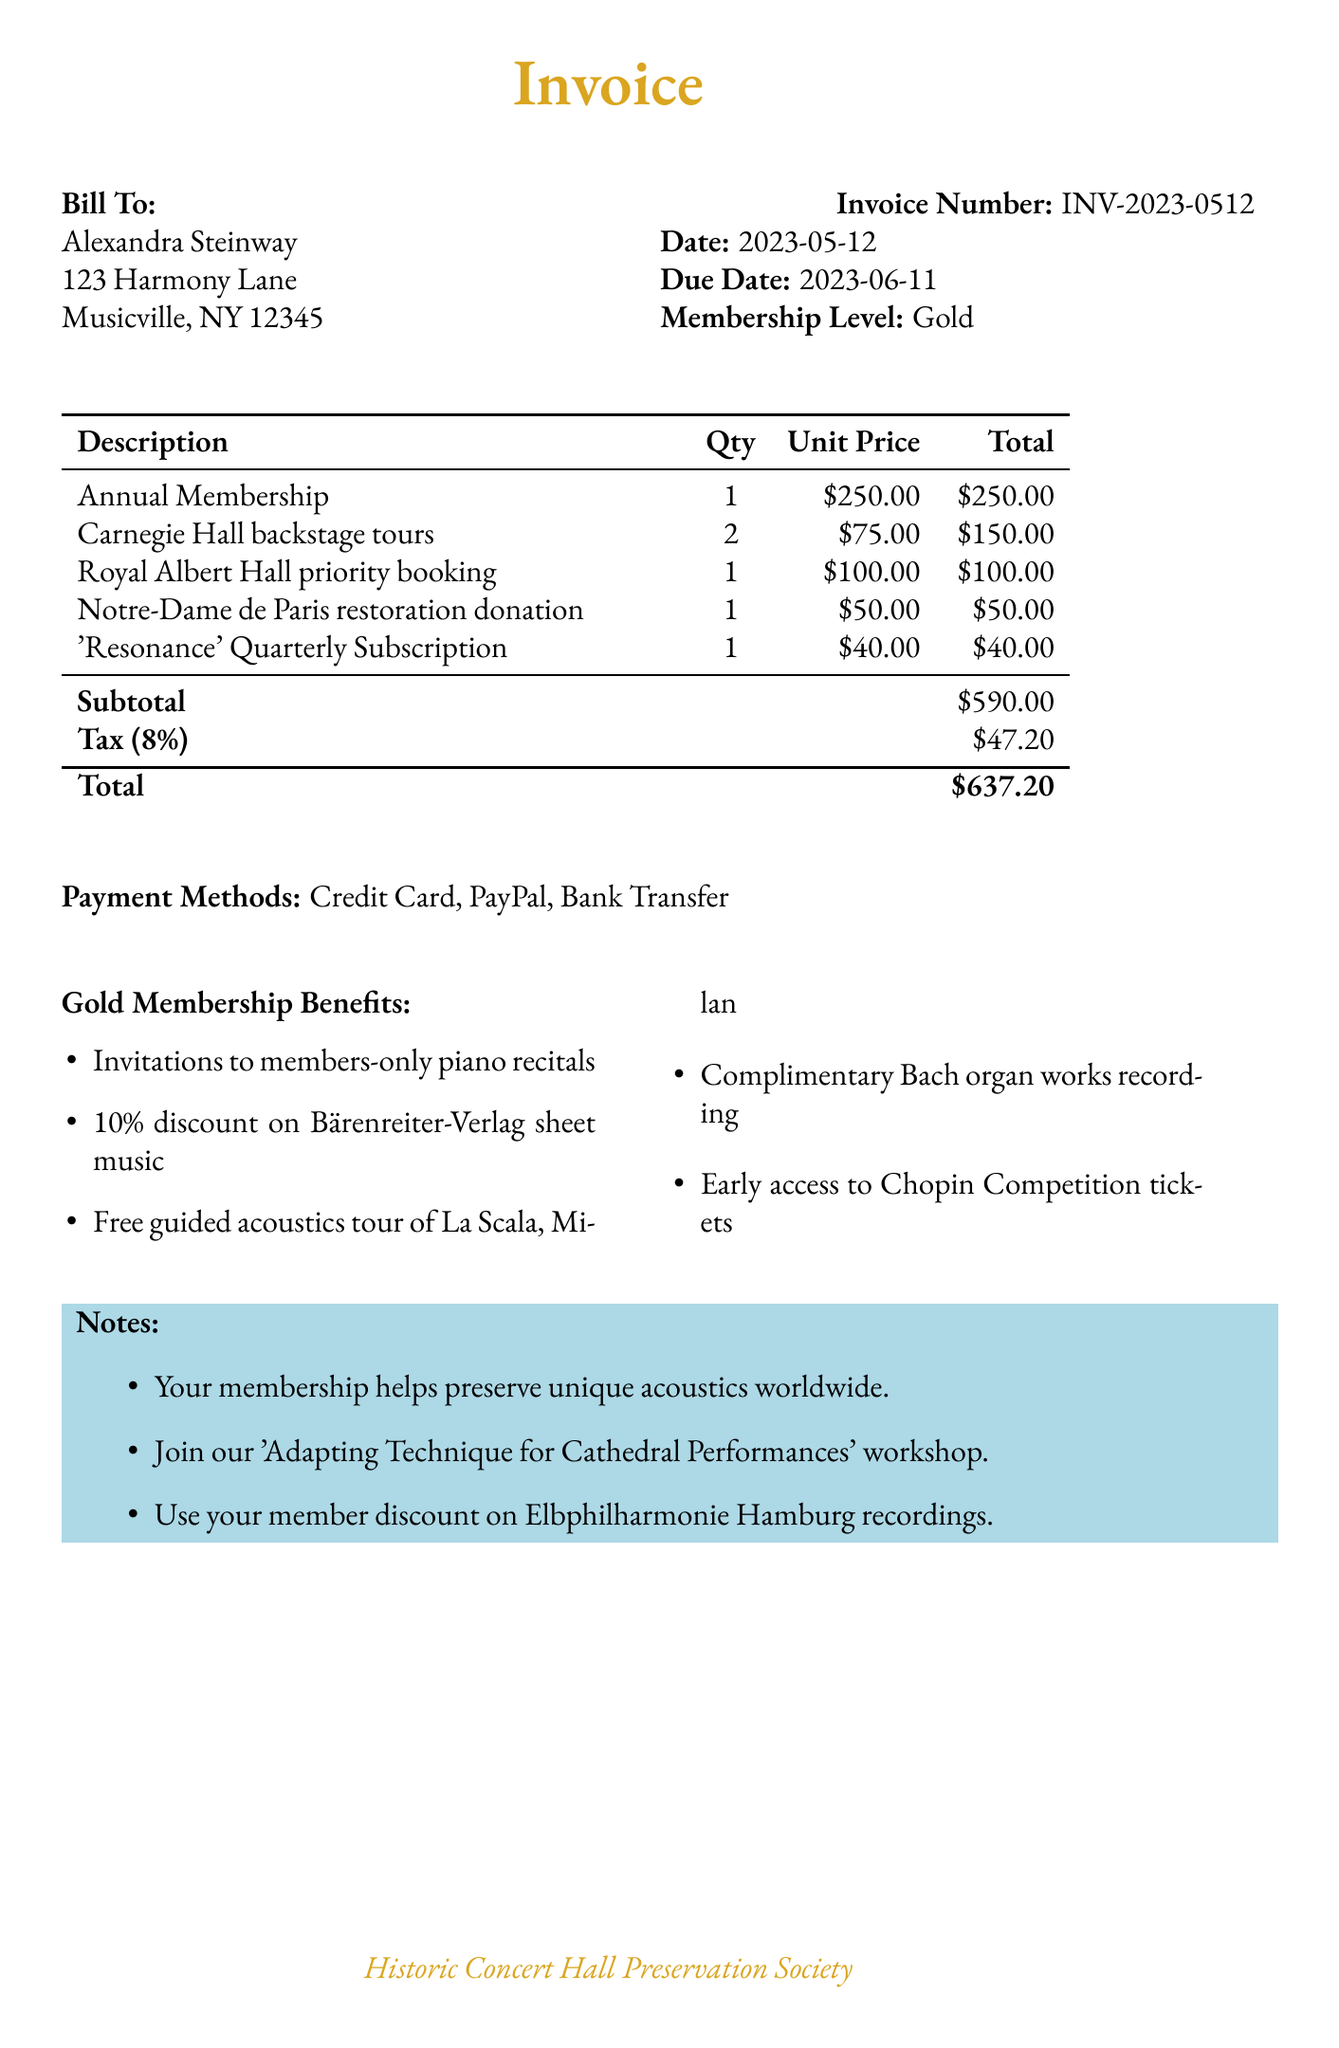What is the invoice number? The invoice number is specified as the unique identifier for the invoice which is INV-2023-0512.
Answer: INV-2023-0512 What is the due date? The due date is the last date for payment specified in the document, which is 2023-06-11.
Answer: 2023-06-11 How much is the total payment? The total payment is presented as the final amount due in the invoice, which sums the subtotal and tax.
Answer: $637.20 What is the membership level? The membership level indicates the type of membership held, which is Gold.
Answer: Gold How many Carnegie Hall backstage tours were purchased? The document lists the quantity of backstage tours purchased, which is 2.
Answer: 2 What is the tax rate applied? The tax rate is mentioned in the document as 8 percent which is used to calculate the tax amount.
Answer: 8% What are the payment methods available? The document specifies the methods of payment accepted for the invoice which are listed clearly.
Answer: Credit Card, PayPal, Bank Transfer What is the subtotal amount? The subtotal amount is presented before tax is added, representing the total prices of all line items.
Answer: $590.00 What is included in the notes? The notes section provides additional information about membership benefits and events but doesn’t specify one detail in particular.
Answer: Membership benefits and upcoming workshops 